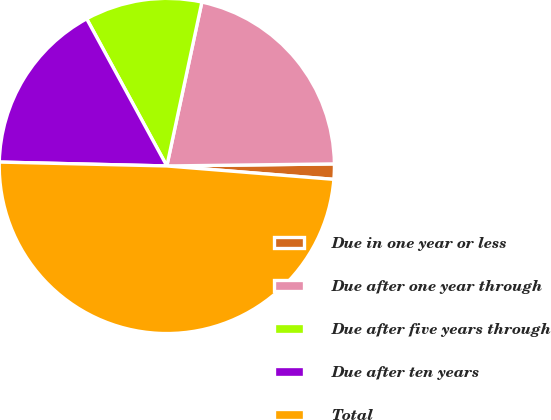<chart> <loc_0><loc_0><loc_500><loc_500><pie_chart><fcel>Due in one year or less<fcel>Due after one year through<fcel>Due after five years through<fcel>Due after ten years<fcel>Total<nl><fcel>1.47%<fcel>21.45%<fcel>11.29%<fcel>16.69%<fcel>49.09%<nl></chart> 